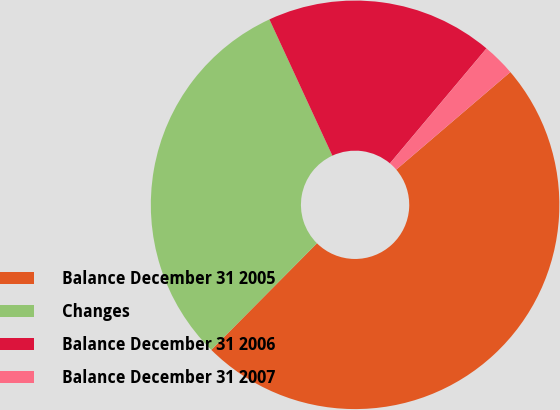<chart> <loc_0><loc_0><loc_500><loc_500><pie_chart><fcel>Balance December 31 2005<fcel>Changes<fcel>Balance December 31 2006<fcel>Balance December 31 2007<nl><fcel>48.69%<fcel>30.68%<fcel>18.01%<fcel>2.62%<nl></chart> 